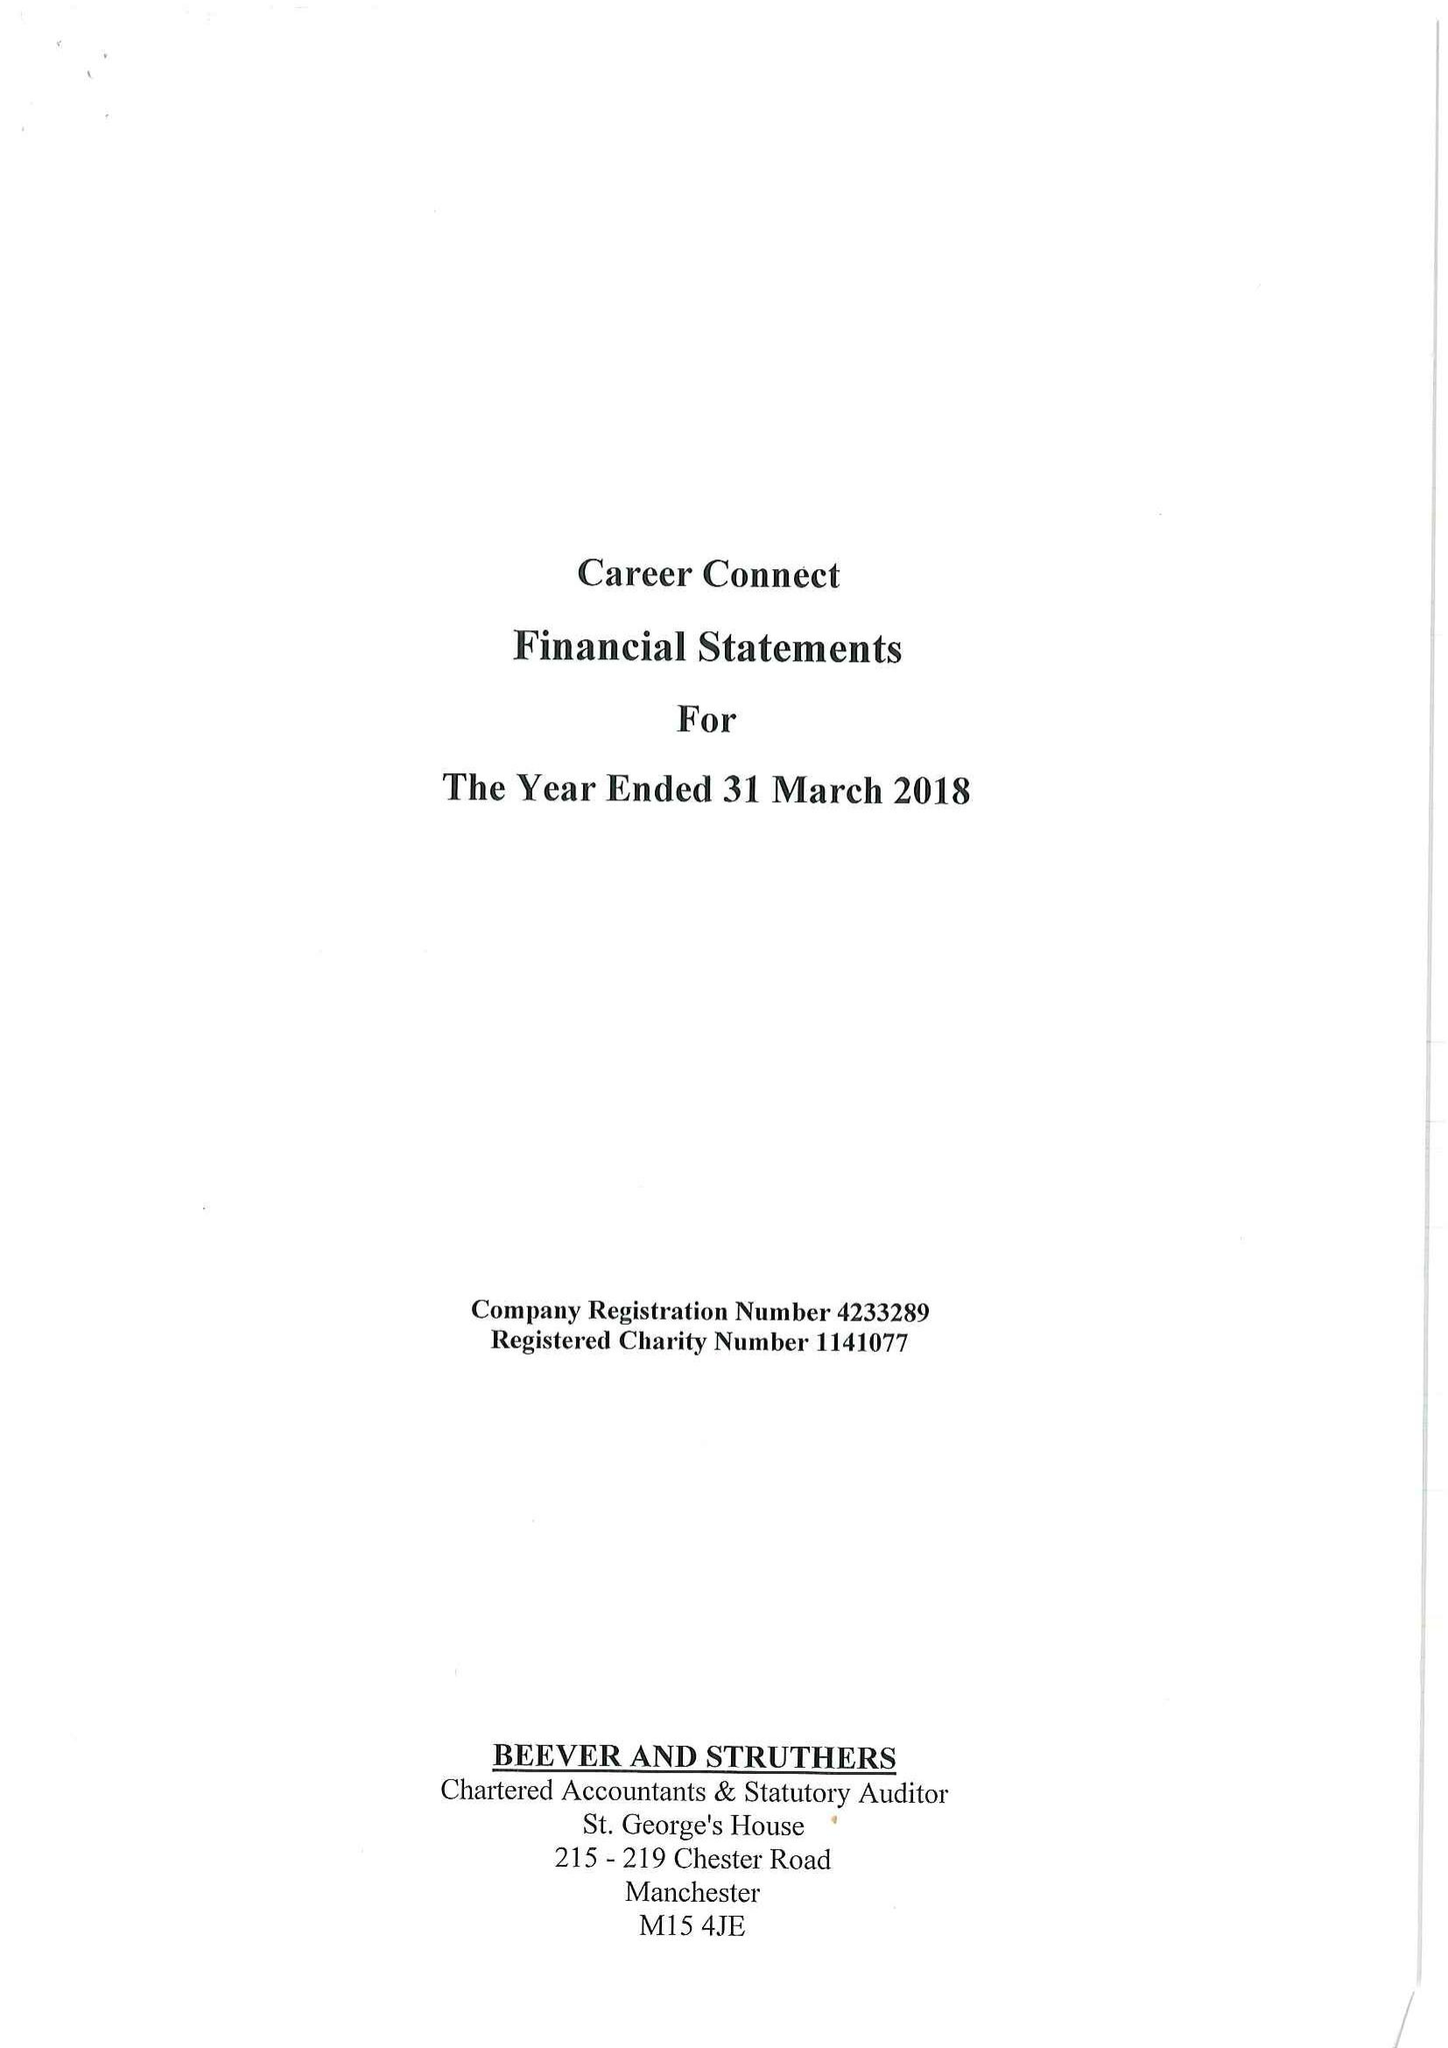What is the value for the income_annually_in_british_pounds?
Answer the question using a single word or phrase. 14446230.00 